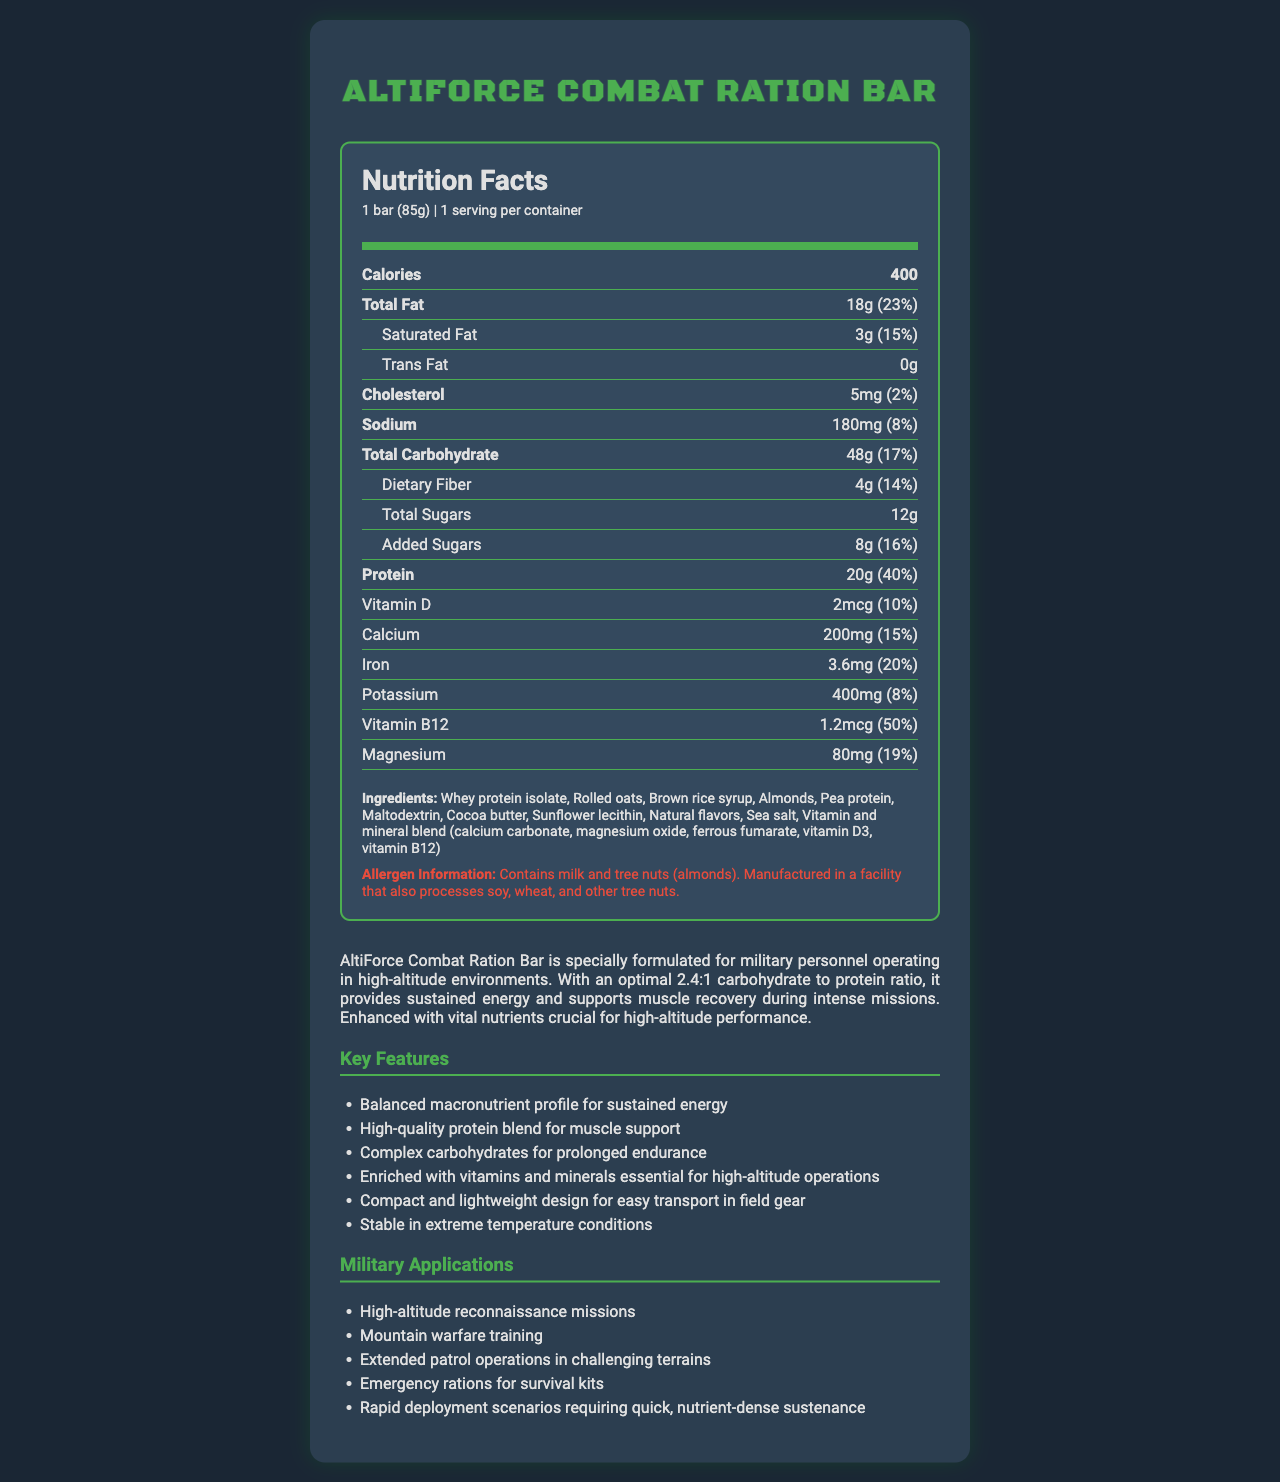what is the serving size of the AltiForce Combat Ration Bar? The serving size is stated in the document as "1 bar (85g)".
Answer: 1 bar (85g) how many calories does one serving of the AltiForce Combat Ration Bar contain? The document specifies that each serving of the bar contains 400 calories.
Answer: 400 how much protein is in the AltiForce Combat Ration Bar, and what percentage of the daily value does it provide? The document lists the protein content as 20g, which is 40% of the daily value.
Answer: 20g, 40% what is the carbohydrate to protein ratio in the AltiForce Combat Ration Bar? According to the product description, the carbohydrate to protein ratio is 2.4:1.
Answer: 2.4:1 how much total fat does one serving of the AltiForce Combat Ration Bar contain? The document specifies that the bar contains 18g of total fat per serving.
Answer: 18g which ingredients are primary sources of protein in the AltiForce Combat Ration Bar? The ingredients section lists whey protein isolate and pea protein as primary sources of protein.
Answer: Whey protein isolate, Pea protein how much total carbohydrate is in one serving, and what percentage of the daily value does it provide? The document states that one serving contains 48g of total carbohydrate, which is 17% of the daily value.
Answer: 48g, 17% how much dietary fiber does each bar contain? The document indicates that each bar contains 4g of dietary fiber.
Answer: 4g which vitamins and minerals are specifically mentioned in the document? A. Vitamin A, Vitamin C, Calcium B. Vitamin D, Calcium, Iron C. Vitamin E, Vitamin K, Magnesium The document mentions Vitamin D, Calcium, and Iron.
Answer: B which of the following military applications is NOT listed for the AltiForce Combat Ration Bar? 1. High-altitude reconnaissance missions 2. Submarine operations 3. Mountain warfare training 4. Emergency rations for survival kits The document lists high-altitude reconnaissance missions, mountain warfare training, and emergency rations for survival kits but not submarine operations.
Answer: 2 is the AltiForce Combat Ration Bar suitable for people with nut allergies? The allergen information specifies that the bar contains tree nuts (almonds) and is manufactured in a facility that processes other tree nuts.
Answer: No does the AltiForce Combat Ration Bar contain any added sugars? The document states that the bar contains 8g of added sugars.
Answer: Yes summarize the main idea of the AltiForce Combat Ration Bar document. The summary includes the product description, nutrition facts, and its applications in military operations.
Answer: The AltiForce Combat Ration Bar is a specialized energy bar designed for military personnel operating in high-altitude environments. With a balanced macronutrient profile featuring a carbohydrate to protein ratio of 2.4:1, it provides sustained energy and muscle support. It contains 400 calories per serving, 20g of protein, and 48g of carbohydrates. It is enriched with vitamins and minerals essential for high-altitude performance and designed for various military applications such as high-altitude reconnaissance, mountain warfare, and emergency rations. what is the main source of sweetness in the AltiForce Combat Ration Bar? The document mentions total and added sugars but does not specify the main source of sweetness.
Answer: Cannot be determined what is the purpose of the AltiForce Combat Ration Bar's vitamin and mineral blend? The product description states that the bar is enhanced with vital nutrients crucial for high-altitude performance.
Answer: To provide essential nutrients for high-altitude performance how many milligrams of iron does one serving of the AltiForce Combat Ration Bar have? The document lists the iron content as 3.6mg per serving.
Answer: 3.6mg is the AltiForce Combat Ration Bar designed to be stable in extreme temperature conditions? The key features section mentions that the bar is stable in extreme temperature conditions.
Answer: Yes 